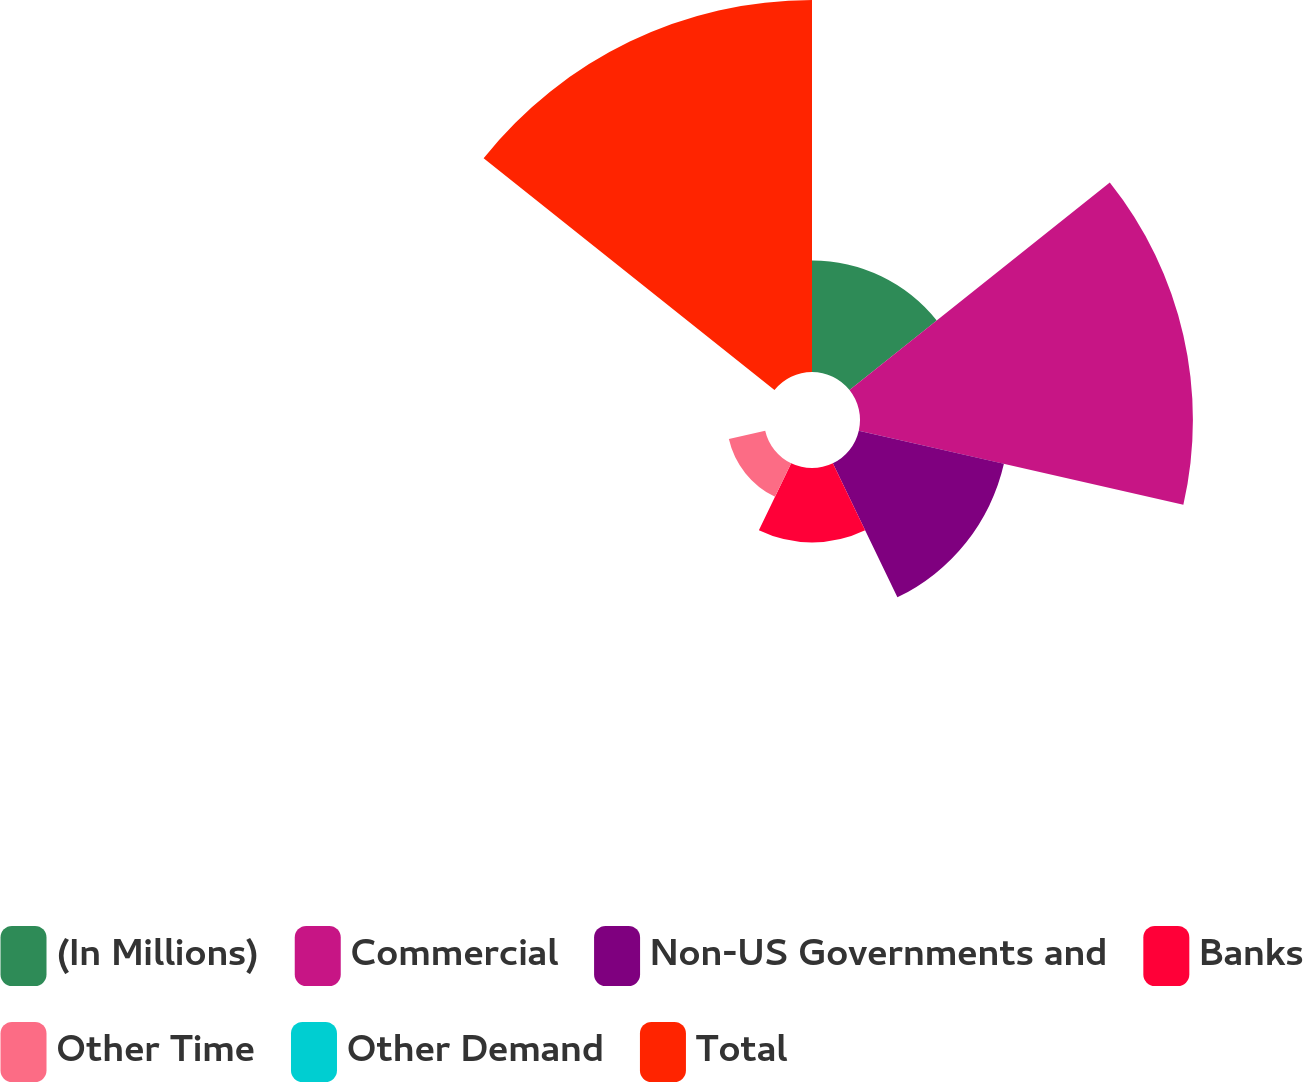Convert chart to OTSL. <chart><loc_0><loc_0><loc_500><loc_500><pie_chart><fcel>(In Millions)<fcel>Commercial<fcel>Non-US Governments and<fcel>Banks<fcel>Other Time<fcel>Other Demand<fcel>Total<nl><fcel>10.36%<fcel>30.91%<fcel>13.82%<fcel>6.91%<fcel>3.46%<fcel>0.0%<fcel>34.54%<nl></chart> 